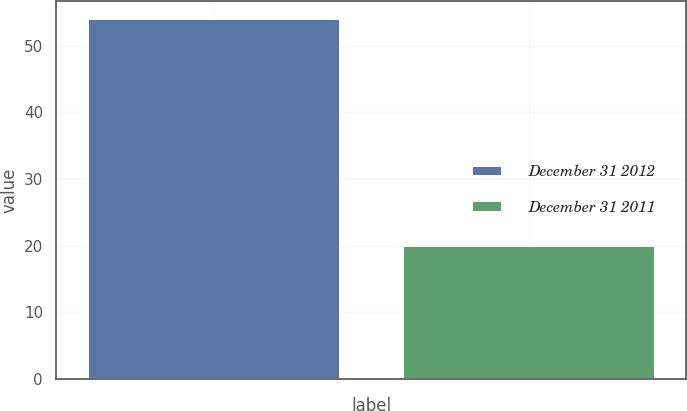Convert chart to OTSL. <chart><loc_0><loc_0><loc_500><loc_500><bar_chart><fcel>December 31 2012<fcel>December 31 2011<nl><fcel>54<fcel>20<nl></chart> 